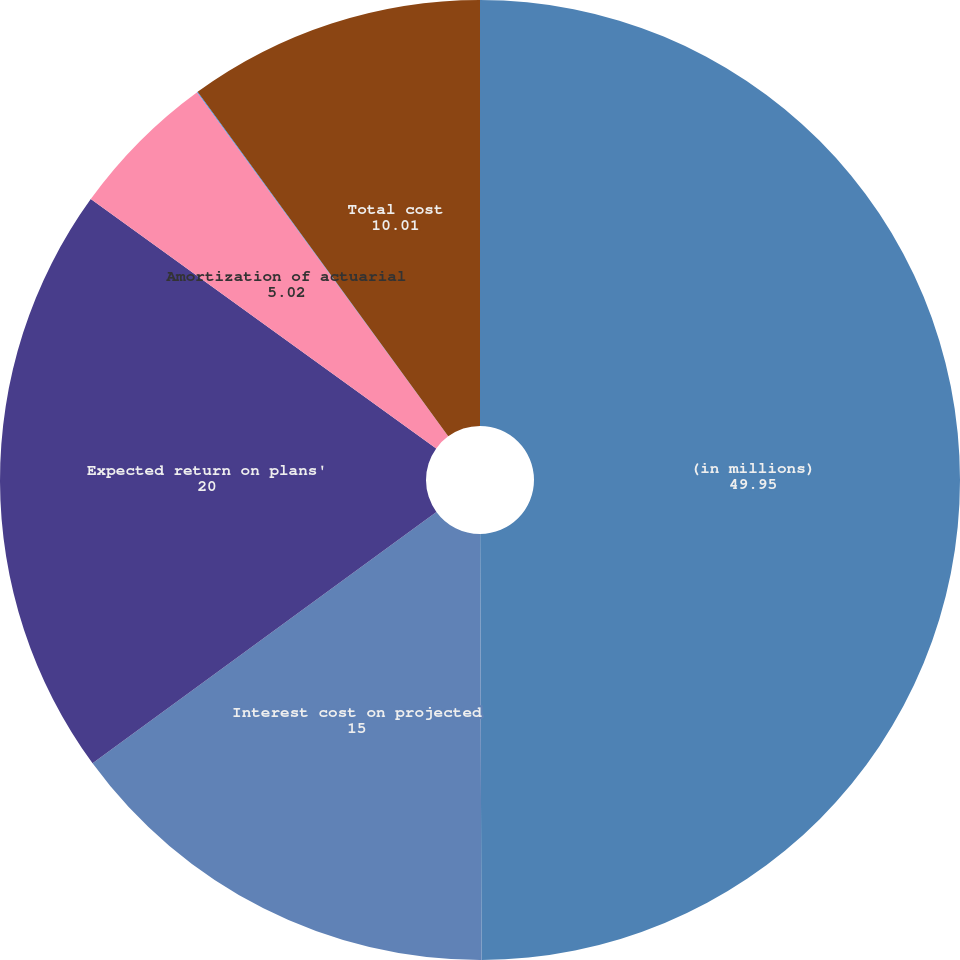Convert chart. <chart><loc_0><loc_0><loc_500><loc_500><pie_chart><fcel>(in millions)<fcel>Interest cost on projected<fcel>Expected return on plans'<fcel>Amortization of actuarial<fcel>Amortization of prior service<fcel>Total cost<nl><fcel>49.95%<fcel>15.0%<fcel>20.0%<fcel>5.02%<fcel>0.02%<fcel>10.01%<nl></chart> 